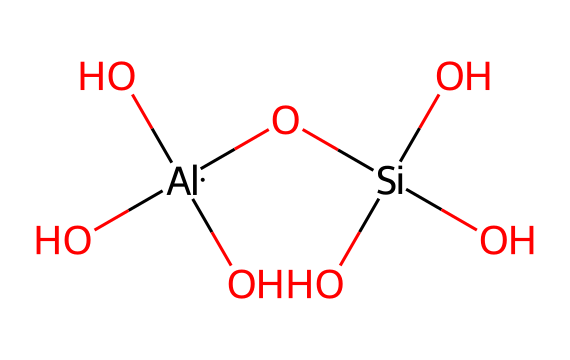what is the primary metal present in this compound? The chemical structure shows the presence of aluminum, which is indicated by the 'Al' in the SMILES representation.
Answer: aluminum how many silicon atoms are in this compound? By examining the SMILES representation, there is one occurrence of the 'Si' element, indicating that there is one silicon atom present.
Answer: one what is the total number of hydroxyl (OH) groups in this compound? The structure contains three 'O' atoms connected to hydroxyl groups where each oxygen is bonded to a hydrogen atom. This means there are three hydroxyl groups in total.
Answer: three which classes of ceramics relate to this chemical structure? The presence of aluminum and silicon oxides suggests that this compound belongs to the category of aluminosilicates.
Answer: aluminosilicates what are the overall oxidation states of the aluminum and silicon in the structure? In this chemical, aluminum typically exhibits a +3 oxidation state, while silicon usually has a +4 oxidation state; this can be deduced from their bonding and typical behavior in ceramics.
Answer: +3 and +4 